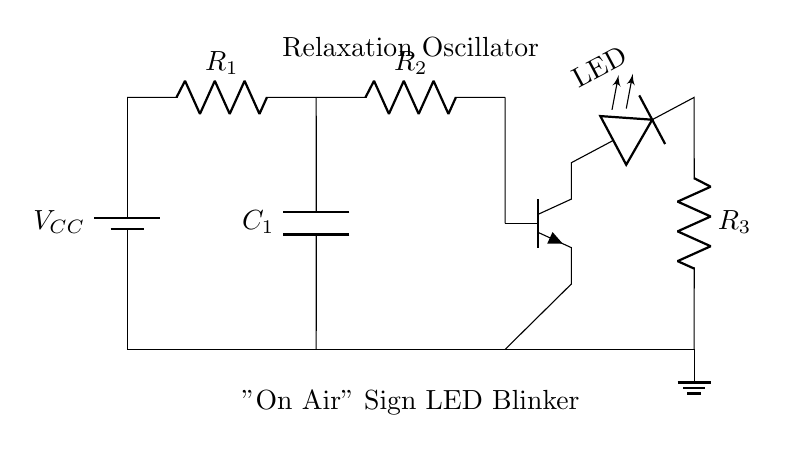What is the type of oscillator shown in the circuit? The circuit is labeled as a "Relaxation Oscillator," which indicates its operation relies on the charging and discharging of a capacitor to create oscillation.
Answer: Relaxation Oscillator What component is used to generate the blinking light for the "On Air" sign? The circuit contains a light-emitting diode indicated as LED, which is specifically connected to illustrate its function as the blinking indicator for the "On Air" sign.
Answer: LED How many resistors are present in the circuit? There are two resistors labeled as R1 and R2, which are necessary for controlling the charging and discharging currents in the configuration of the relaxation oscillator.
Answer: 2 What is the role of capacitor C1 in this circuit? Capacitor C1 is essential for the timing mechanism of the oscillator; it charges and discharges, influencing the frequency and duration of the LED blinking cycle.
Answer: Timing Which active component is present in this oscillator circuit? The circuit features an NPN transistor, designated as Q, which acts as a switch, controlling the LED based on the state of the capacitor's charge.
Answer: Transistor What does the position of the LED indicate about the circuit behavior? The LED's position in the circuit shows that it is connected to the output of the transistor, suggesting that the LED turns on and off depending on the charging state of the capacitor, reflecting the oscillatory behavior.
Answer: Blinking What does resistor R3 indicate in relation to the LED? Resistor R3 functions as a current-limiting resistor for the LED, ensuring that the current through the LED does not exceed its maximum rating, thus preventing damage while allowing it to blink.
Answer: Current limiting 